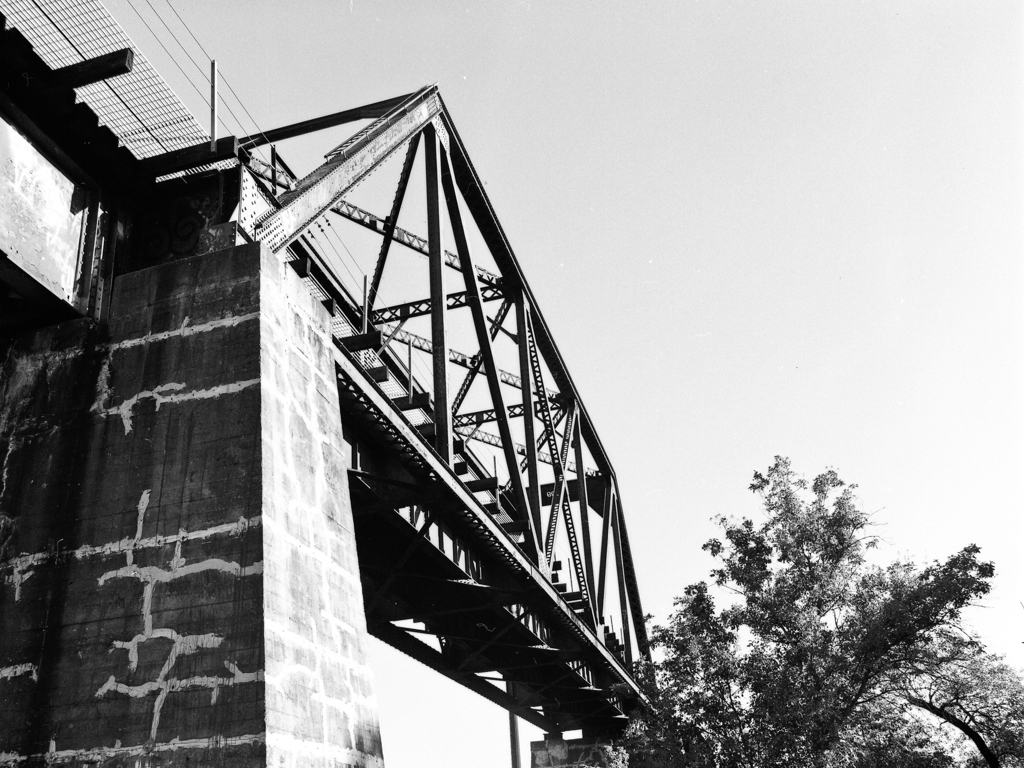Could you comment on the aesthetic qualities or the era this bridge might come from? The bridge's metal truss design and the industrial appearance suggest that it could date from the late 19th to mid-20th century, a time when such sturdy, functional structures were commonly built. Aesthetically, the bridge has a raw, utilitarian beauty, characterized by its geometric patterns and the contrast of man-made architecture against the natural backdrop. 